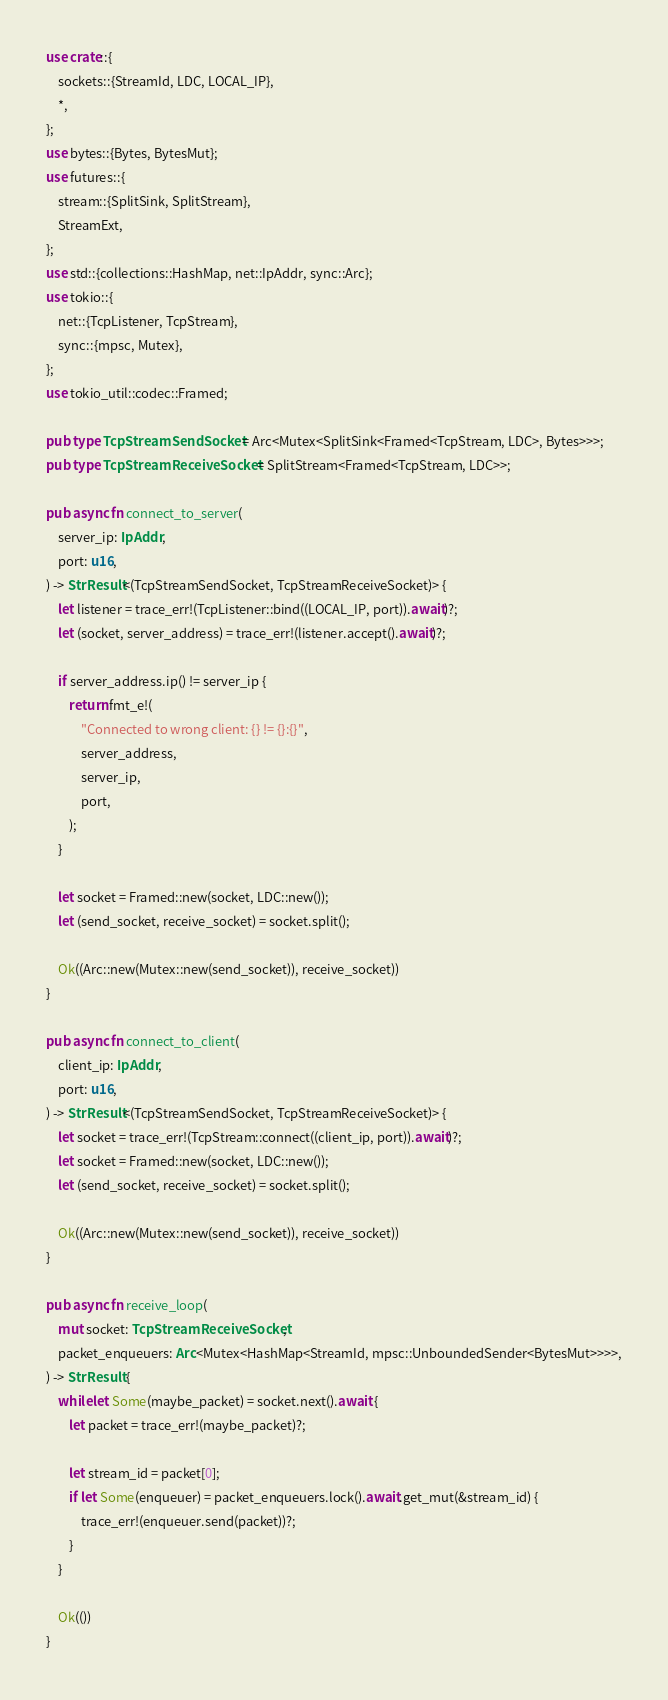<code> <loc_0><loc_0><loc_500><loc_500><_Rust_>use crate::{
    sockets::{StreamId, LDC, LOCAL_IP},
    *,
};
use bytes::{Bytes, BytesMut};
use futures::{
    stream::{SplitSink, SplitStream},
    StreamExt,
};
use std::{collections::HashMap, net::IpAddr, sync::Arc};
use tokio::{
    net::{TcpListener, TcpStream},
    sync::{mpsc, Mutex},
};
use tokio_util::codec::Framed;

pub type TcpStreamSendSocket = Arc<Mutex<SplitSink<Framed<TcpStream, LDC>, Bytes>>>;
pub type TcpStreamReceiveSocket = SplitStream<Framed<TcpStream, LDC>>;

pub async fn connect_to_server(
    server_ip: IpAddr,
    port: u16,
) -> StrResult<(TcpStreamSendSocket, TcpStreamReceiveSocket)> {
    let listener = trace_err!(TcpListener::bind((LOCAL_IP, port)).await)?;
    let (socket, server_address) = trace_err!(listener.accept().await)?;

    if server_address.ip() != server_ip {
        return fmt_e!(
            "Connected to wrong client: {} != {}:{}",
            server_address,
            server_ip,
            port,
        );
    }

    let socket = Framed::new(socket, LDC::new());
    let (send_socket, receive_socket) = socket.split();

    Ok((Arc::new(Mutex::new(send_socket)), receive_socket))
}

pub async fn connect_to_client(
    client_ip: IpAddr,
    port: u16,
) -> StrResult<(TcpStreamSendSocket, TcpStreamReceiveSocket)> {
    let socket = trace_err!(TcpStream::connect((client_ip, port)).await)?;
    let socket = Framed::new(socket, LDC::new());
    let (send_socket, receive_socket) = socket.split();

    Ok((Arc::new(Mutex::new(send_socket)), receive_socket))
}

pub async fn receive_loop(
    mut socket: TcpStreamReceiveSocket,
    packet_enqueuers: Arc<Mutex<HashMap<StreamId, mpsc::UnboundedSender<BytesMut>>>>,
) -> StrResult {
    while let Some(maybe_packet) = socket.next().await {
        let packet = trace_err!(maybe_packet)?;

        let stream_id = packet[0];
        if let Some(enqueuer) = packet_enqueuers.lock().await.get_mut(&stream_id) {
            trace_err!(enqueuer.send(packet))?;
        }
    }

    Ok(())
}
</code> 